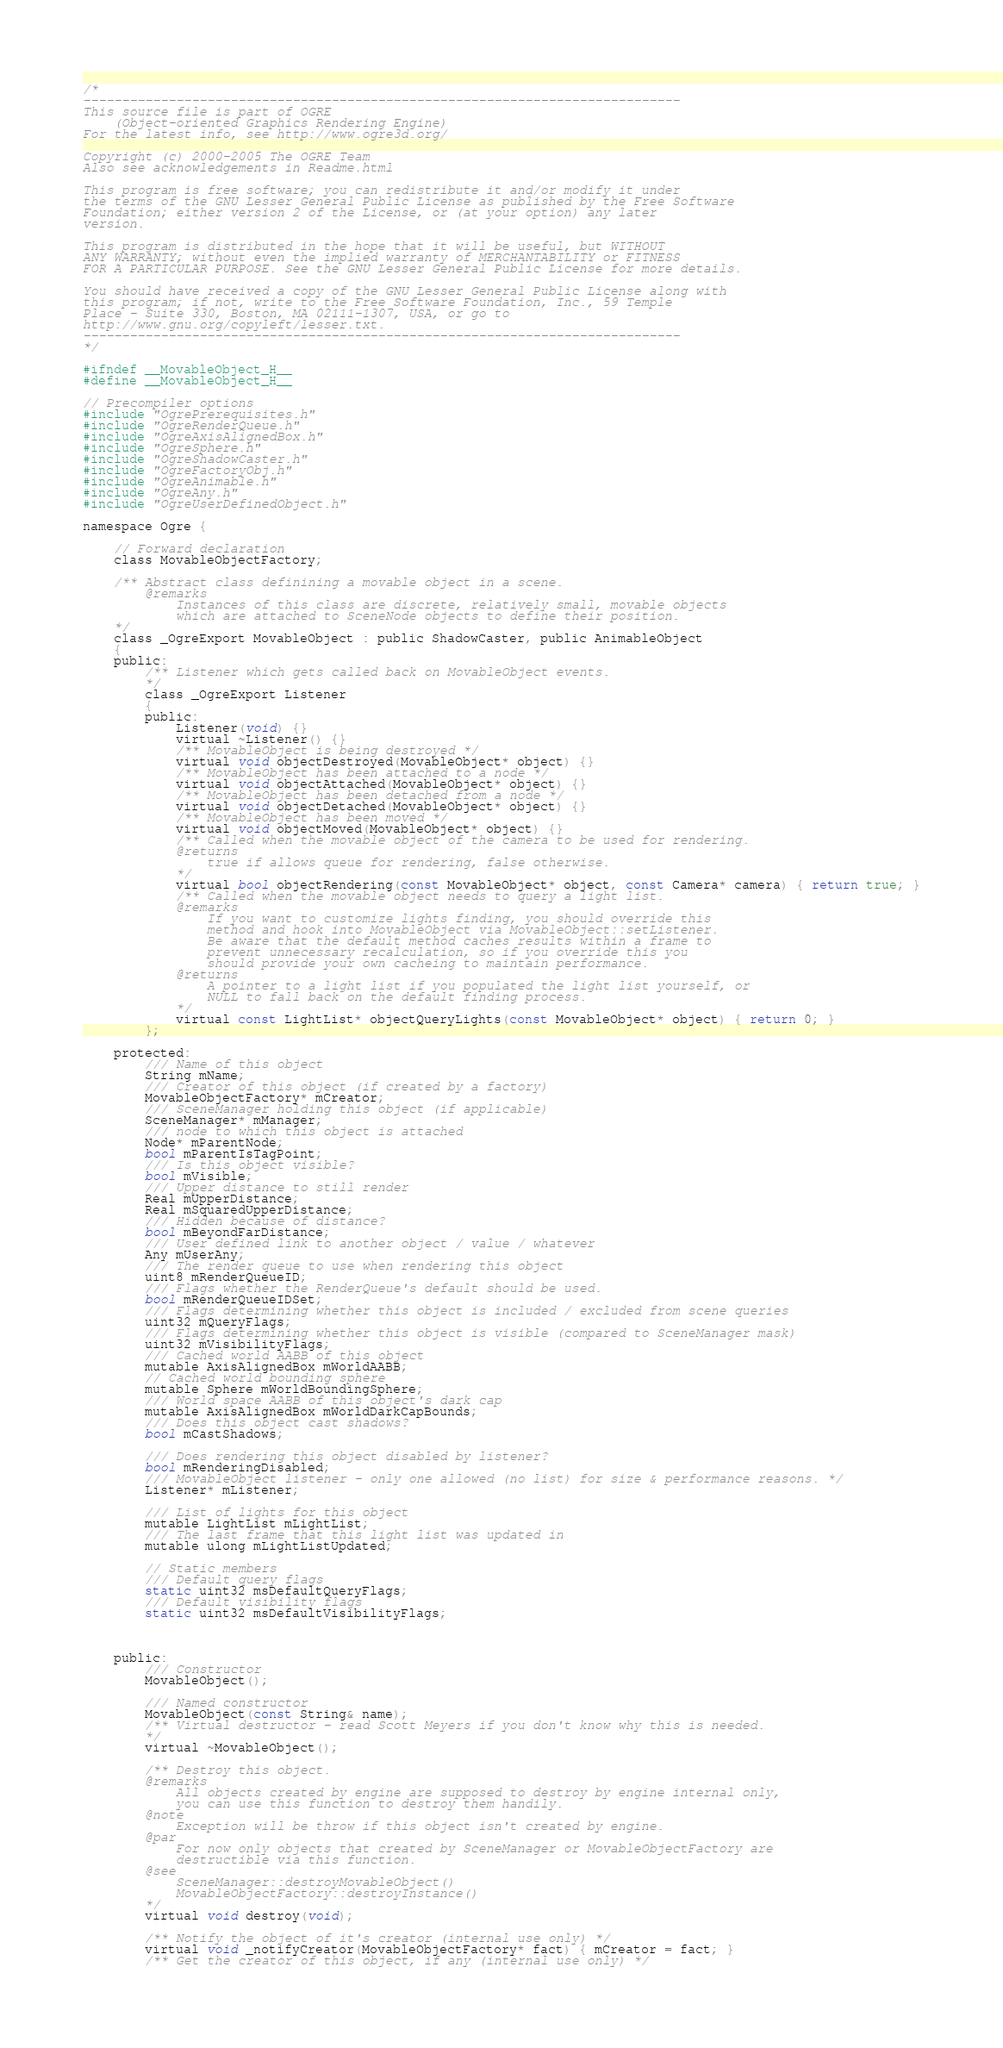Convert code to text. <code><loc_0><loc_0><loc_500><loc_500><_C_>/*
-----------------------------------------------------------------------------
This source file is part of OGRE
    (Object-oriented Graphics Rendering Engine)
For the latest info, see http://www.ogre3d.org/

Copyright (c) 2000-2005 The OGRE Team
Also see acknowledgements in Readme.html

This program is free software; you can redistribute it and/or modify it under
the terms of the GNU Lesser General Public License as published by the Free Software
Foundation; either version 2 of the License, or (at your option) any later
version.

This program is distributed in the hope that it will be useful, but WITHOUT
ANY WARRANTY; without even the implied warranty of MERCHANTABILITY or FITNESS
FOR A PARTICULAR PURPOSE. See the GNU Lesser General Public License for more details.

You should have received a copy of the GNU Lesser General Public License along with
this program; if not, write to the Free Software Foundation, Inc., 59 Temple
Place - Suite 330, Boston, MA 02111-1307, USA, or go to
http://www.gnu.org/copyleft/lesser.txt.
-----------------------------------------------------------------------------
*/

#ifndef __MovableObject_H__
#define __MovableObject_H__

// Precompiler options
#include "OgrePrerequisites.h"
#include "OgreRenderQueue.h"
#include "OgreAxisAlignedBox.h"
#include "OgreSphere.h"
#include "OgreShadowCaster.h"
#include "OgreFactoryObj.h"
#include "OgreAnimable.h"
#include "OgreAny.h"
#include "OgreUserDefinedObject.h"

namespace Ogre {

	// Forward declaration
	class MovableObjectFactory;

    /** Abstract class definining a movable object in a scene.
        @remarks
            Instances of this class are discrete, relatively small, movable objects
            which are attached to SceneNode objects to define their position.
    */
    class _OgreExport MovableObject : public ShadowCaster, public AnimableObject
    {
    public:
        /** Listener which gets called back on MovableObject events.
        */
        class _OgreExport Listener
        {
        public:
            Listener(void) {}
            virtual ~Listener() {}
            /** MovableObject is being destroyed */
            virtual void objectDestroyed(MovableObject* object) {}
            /** MovableObject has been attached to a node */
            virtual void objectAttached(MovableObject* object) {}
            /** MovableObject has been detached from a node */
            virtual void objectDetached(MovableObject* object) {}
            /** MovableObject has been moved */
            virtual void objectMoved(MovableObject* object) {}
            /** Called when the movable object of the camera to be used for rendering.
            @returns
                true if allows queue for rendering, false otherwise.
            */
            virtual bool objectRendering(const MovableObject* object, const Camera* camera) { return true; }
            /** Called when the movable object needs to query a light list.
            @remarks
                If you want to customize lights finding, you should override this
                method and hook into MovableObject via MovableObject::setListener.
				Be aware that the default method caches results within a frame to 
				prevent unnecessary recalculation, so if you override this you 
				should provide your own cacheing to maintain performance.
            @returns
                A pointer to a light list if you populated the light list yourself, or
                NULL to fall back on the default finding process.
            */
            virtual const LightList* objectQueryLights(const MovableObject* object) { return 0; }
        };

    protected:
		/// Name of this object
		String mName;
		/// Creator of this object (if created by a factory)
		MovableObjectFactory* mCreator;
		/// SceneManager holding this object (if applicable)
		SceneManager* mManager;
        /// node to which this object is attached
        Node* mParentNode;
        bool mParentIsTagPoint;
        /// Is this object visible?
        bool mVisible;
		/// Upper distance to still render
		Real mUpperDistance;
		Real mSquaredUpperDistance;
		/// Hidden because of distance?
		bool mBeyondFarDistance;
		/// User defined link to another object / value / whatever
		Any mUserAny;
        /// The render queue to use when rendering this object
        uint8 mRenderQueueID;
		/// Flags whether the RenderQueue's default should be used.
		bool mRenderQueueIDSet;
        /// Flags determining whether this object is included / excluded from scene queries
        uint32 mQueryFlags;
        /// Flags determining whether this object is visible (compared to SceneManager mask)
        uint32 mVisibilityFlags;
        /// Cached world AABB of this object
        mutable AxisAlignedBox mWorldAABB;
		// Cached world bounding sphere
		mutable Sphere mWorldBoundingSphere;
        /// World space AABB of this object's dark cap
        mutable AxisAlignedBox mWorldDarkCapBounds;
        /// Does this object cast shadows?
        bool mCastShadows;

        /// Does rendering this object disabled by listener?
        bool mRenderingDisabled;
        /// MovableObject listener - only one allowed (no list) for size & performance reasons. */
        Listener* mListener;

        /// List of lights for this object
        mutable LightList mLightList;
        /// The last frame that this light list was updated in
        mutable ulong mLightListUpdated;

		// Static members
		/// Default query flags
		static uint32 msDefaultQueryFlags;
		/// Default visibility flags
		static uint32 msDefaultVisibilityFlags;



    public:
        /// Constructor
        MovableObject();

		/// Named constructor
		MovableObject(const String& name);
        /** Virtual destructor - read Scott Meyers if you don't know why this is needed.
        */
        virtual ~MovableObject();

        /** Destroy this object.
        @remarks
            All objects created by engine are supposed to destroy by engine internal only,
            you can use this function to destroy them handily.
        @note
            Exception will be throw if this object isn't created by engine.
        @par
            For now only objects that created by SceneManager or MovableObjectFactory are
            destructible via this function.
        @see
            SceneManager::destroyMovableObject()
            MovableObjectFactory::destroyInstance()
        */
        virtual void destroy(void);

		/** Notify the object of it's creator (internal use only) */
		virtual void _notifyCreator(MovableObjectFactory* fact) { mCreator = fact; }
		/** Get the creator of this object, if any (internal use only) */</code> 